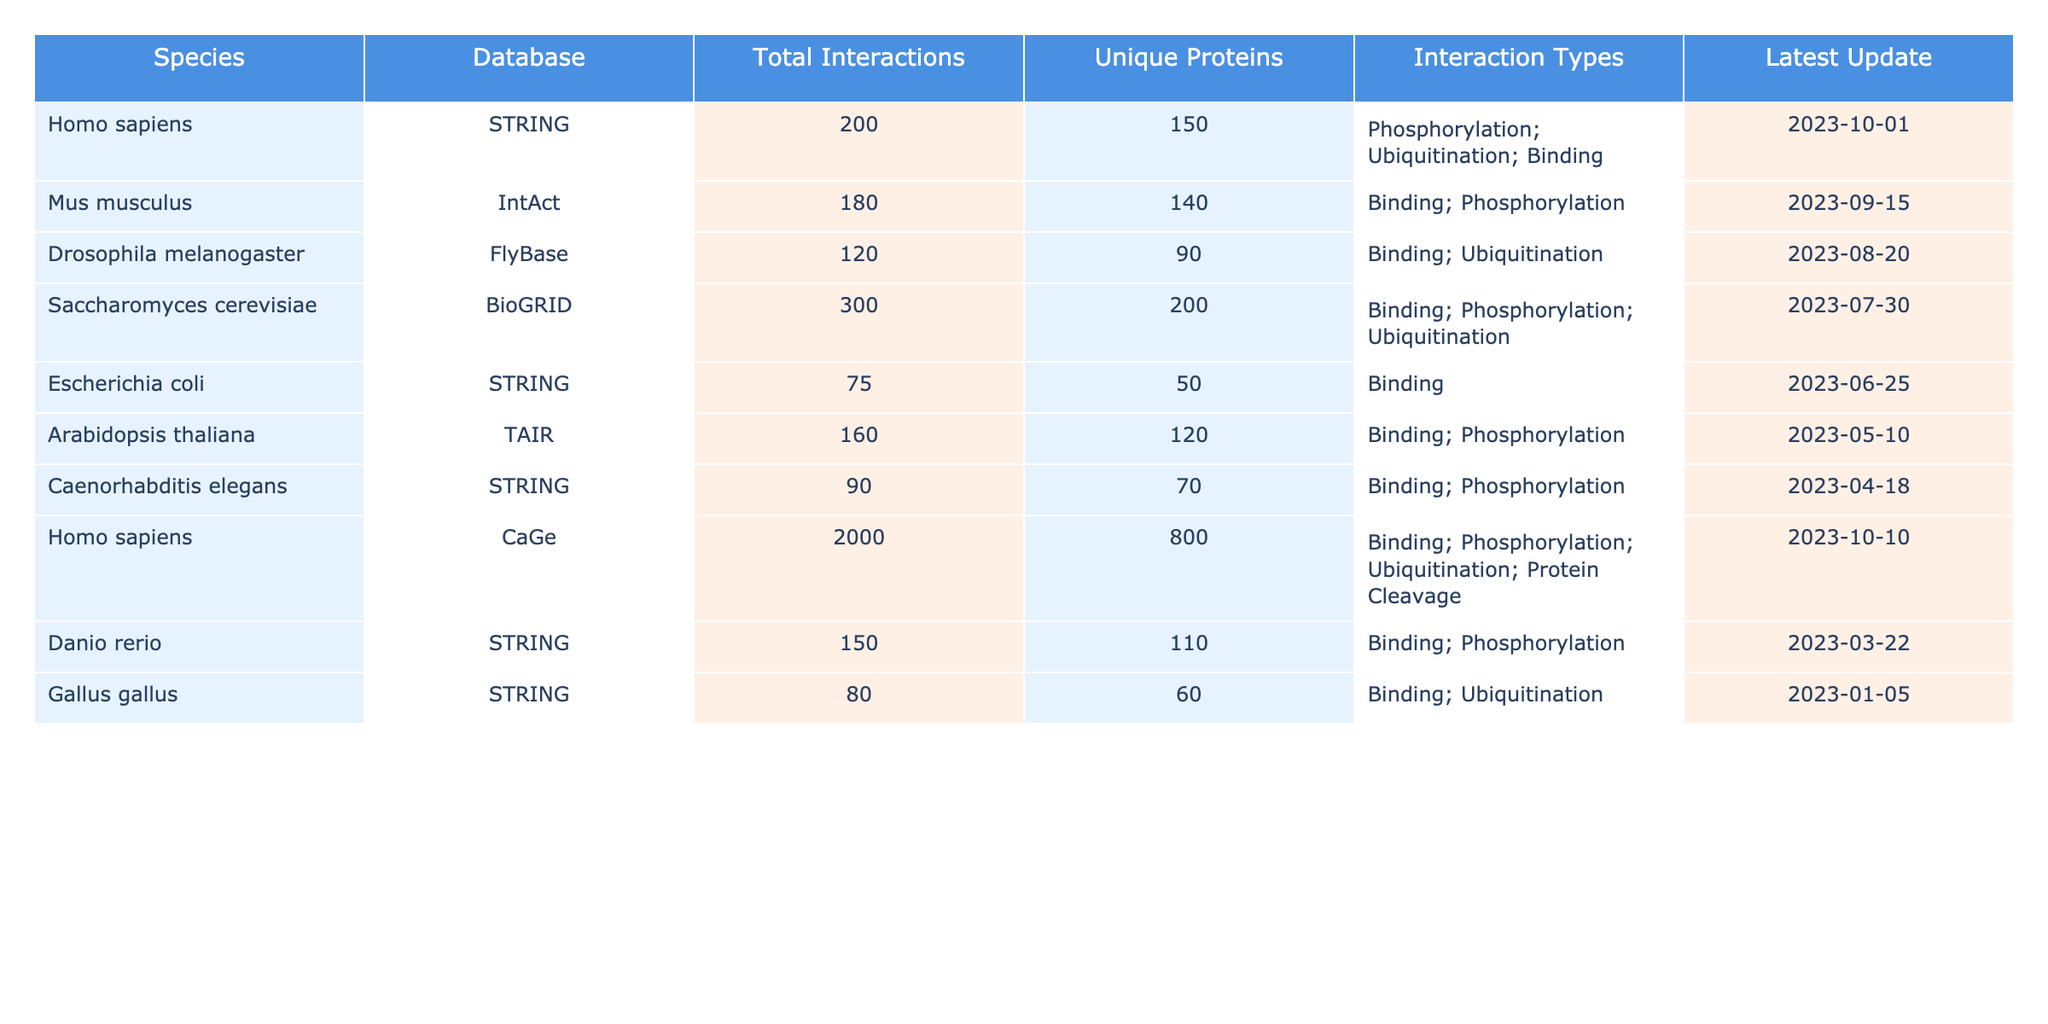What is the total number of interactions for Homo sapiens in the STRING database? The table lists a specific entry for Homo sapiens under the STRING database, with a "Total Interactions" value of 200.
Answer: 200 Which species has the highest number of unique proteins? Looking through the "Unique Proteins" column, Homo sapiens in the CaGe database has the highest count of 800.
Answer: 800 Is there any species that has "Ubiquitination" as one of its interaction types? By examining the "Interaction Types" column, both Homo sapiens (STRING and CaGe) and Drosophila melanogaster have "Ubiquitination" listed as an interaction type.
Answer: Yes What is the average number of total interactions across all species listed? First, we sum the total interactions: (200 + 180 + 120 + 300 + 75 + 160 + 90 + 2000 + 150 + 80) = 3155. Then, we divide by the number of species, which is 10: 3155 / 10 = 315.5.
Answer: 315.5 How many species have more than 150 total interactions? By reviewing the "Total Interactions" column, we count the entries greater than 150, which are Homo sapiens (STRING), Saccharomyces cerevisiae, and Homo sapiens (CaGe), giving us a total of 3 species.
Answer: 3 What is the total number of interactions for Caenorhabditis elegans, and how does it compare to Drosophila melanogaster? The total interactions for Caenorhabditis elegans is 90, while Drosophila melanogaster has 120. The difference is 120 - 90 = 30; therefore, Drosophila melanogaster has 30 more interactions than Caenorhabditis elegans.
Answer: Drosophila melanogaster has 30 more interactions Which database has the largest total interactions? Checking the "Total Interactions" for each database, CaGe for Homo sapiens stands out with 2000 interactions, higher than any other entry in the table.
Answer: CaGe Are there any species listed that only have "Binding" as an interaction type? Reviewing the "Interaction Types" column, Escherichia coli has only "Binding" as an interaction type, meaning there is at least one species with this characteristic.
Answer: Yes What is the difference in unique proteins between Saccharomyces cerevisiae and Mus musculus? Unique proteins for Saccharomyces cerevisiae is 200 and for Mus musculus is 140. The difference is 200 - 140 = 60.
Answer: 60 How many total interactions do Arabidopsis thaliana and Gallus gallus have combined? Adding the "Total Interactions" for both: Arabidopsis thaliana has 160 and Gallus gallus has 80. The combined total is 160 + 80 = 240.
Answer: 240 Is the latest update for all species before September 2023? By checking the "Latest Update" column, the entries for Homo sapiens (CaGe) and Homo sapiens (STRING) are updated in October 2023, indicating that not all updates are before September 2023.
Answer: No 